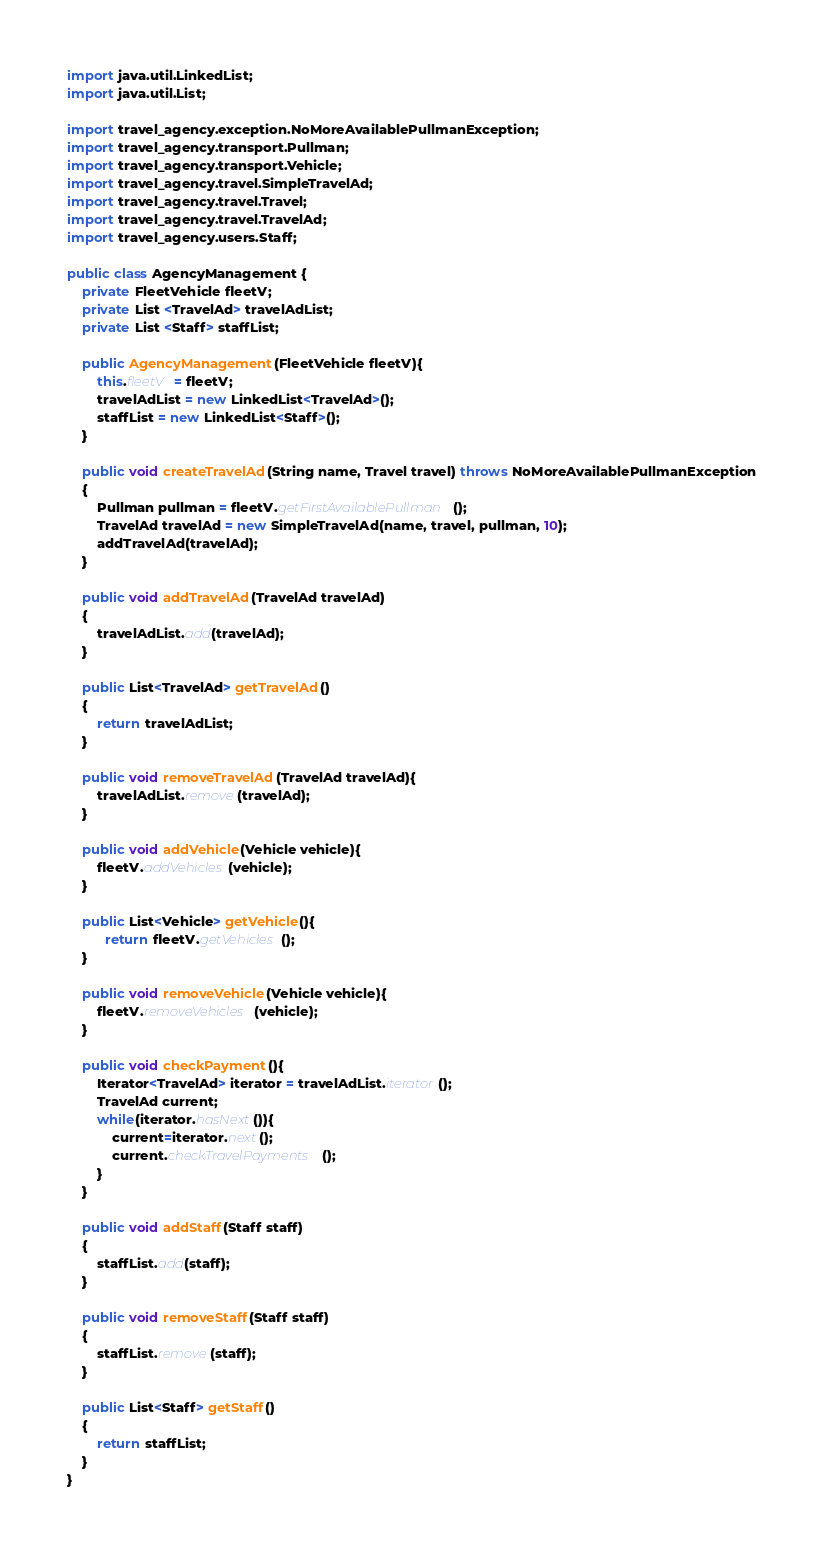Convert code to text. <code><loc_0><loc_0><loc_500><loc_500><_Java_>import java.util.LinkedList;
import java.util.List;

import travel_agency.exception.NoMoreAvailablePullmanException;
import travel_agency.transport.Pullman;
import travel_agency.transport.Vehicle;
import travel_agency.travel.SimpleTravelAd;
import travel_agency.travel.Travel;
import travel_agency.travel.TravelAd;
import travel_agency.users.Staff;

public class AgencyManagement {
	private FleetVehicle fleetV;
	private List <TravelAd> travelAdList;
	private List <Staff> staffList; 
	
	public AgencyManagement(FleetVehicle fleetV){
		this.fleetV = fleetV;
		travelAdList = new LinkedList<TravelAd>();
		staffList = new LinkedList<Staff>();
	}
	
	public void createTravelAd(String name, Travel travel) throws NoMoreAvailablePullmanException
	{
		Pullman pullman = fleetV.getFirstAvailablePullman();
		TravelAd travelAd = new SimpleTravelAd(name, travel, pullman, 10);
		addTravelAd(travelAd);
	}
	
	public void addTravelAd(TravelAd travelAd)
	{
		travelAdList.add(travelAd);
	}
	
	public List<TravelAd> getTravelAd()
	{
		return travelAdList;
	}
	
	public void removeTravelAd(TravelAd travelAd){
		travelAdList.remove(travelAd);
	}
	
	public void addVehicle(Vehicle vehicle){
		fleetV.addVehicles(vehicle);
	}
	
	public List<Vehicle> getVehicle(){
		  return fleetV.getVehicles();
	}
	
	public void removeVehicle(Vehicle vehicle){
		fleetV.removeVehicles(vehicle);
	}
	
	public void checkPayment(){
		Iterator<TravelAd> iterator = travelAdList.iterator();
		TravelAd current;
		while(iterator.hasNext()){
			current=iterator.next();
			current.checkTravelPayments();
		}
	}
	
	public void addStaff(Staff staff)
	{
		staffList.add(staff);
	}
	
	public void removeStaff(Staff staff)
	{
		staffList.remove(staff);
	}
	
	public List<Staff> getStaff()
	{
		return staffList;
	}
}</code> 